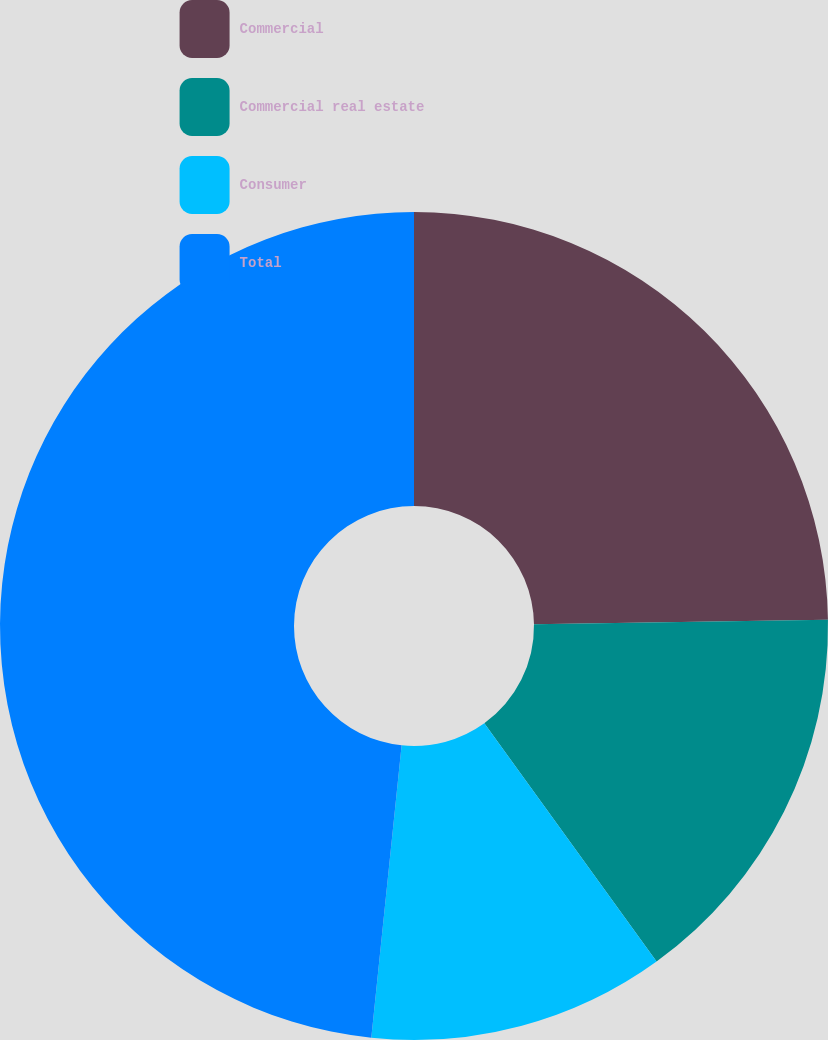<chart> <loc_0><loc_0><loc_500><loc_500><pie_chart><fcel>Commercial<fcel>Commercial real estate<fcel>Consumer<fcel>Total<nl><fcel>24.76%<fcel>15.28%<fcel>11.61%<fcel>48.36%<nl></chart> 